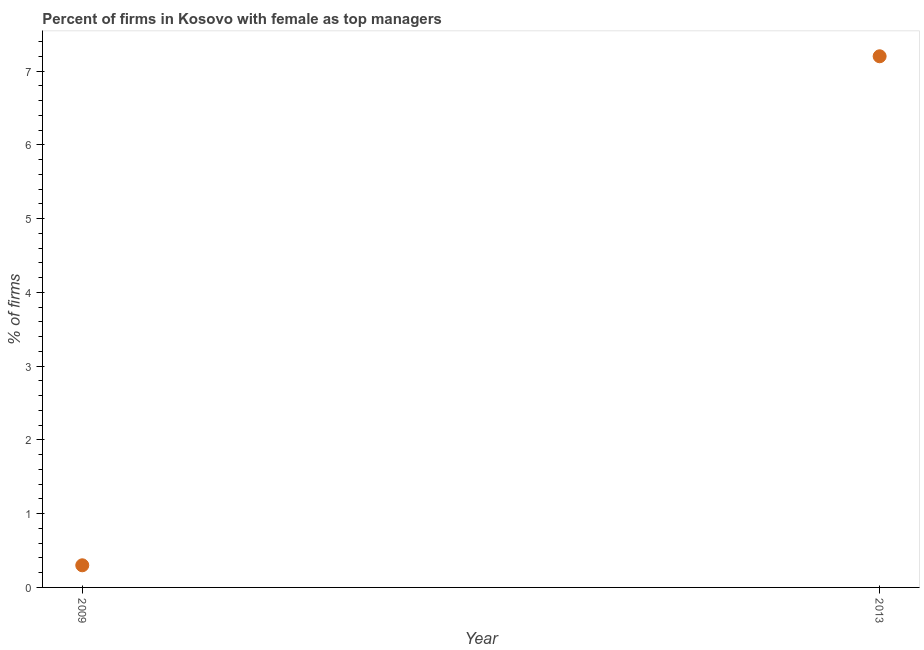Across all years, what is the maximum percentage of firms with female as top manager?
Make the answer very short. 7.2. In which year was the percentage of firms with female as top manager maximum?
Keep it short and to the point. 2013. What is the average percentage of firms with female as top manager per year?
Your answer should be very brief. 3.75. What is the median percentage of firms with female as top manager?
Keep it short and to the point. 3.75. In how many years, is the percentage of firms with female as top manager greater than 6.6 %?
Give a very brief answer. 1. What is the ratio of the percentage of firms with female as top manager in 2009 to that in 2013?
Offer a very short reply. 0.04. How many years are there in the graph?
Your response must be concise. 2. Are the values on the major ticks of Y-axis written in scientific E-notation?
Ensure brevity in your answer.  No. Does the graph contain any zero values?
Keep it short and to the point. No. What is the title of the graph?
Offer a very short reply. Percent of firms in Kosovo with female as top managers. What is the label or title of the Y-axis?
Your response must be concise. % of firms. What is the difference between the % of firms in 2009 and 2013?
Your answer should be compact. -6.9. What is the ratio of the % of firms in 2009 to that in 2013?
Ensure brevity in your answer.  0.04. 